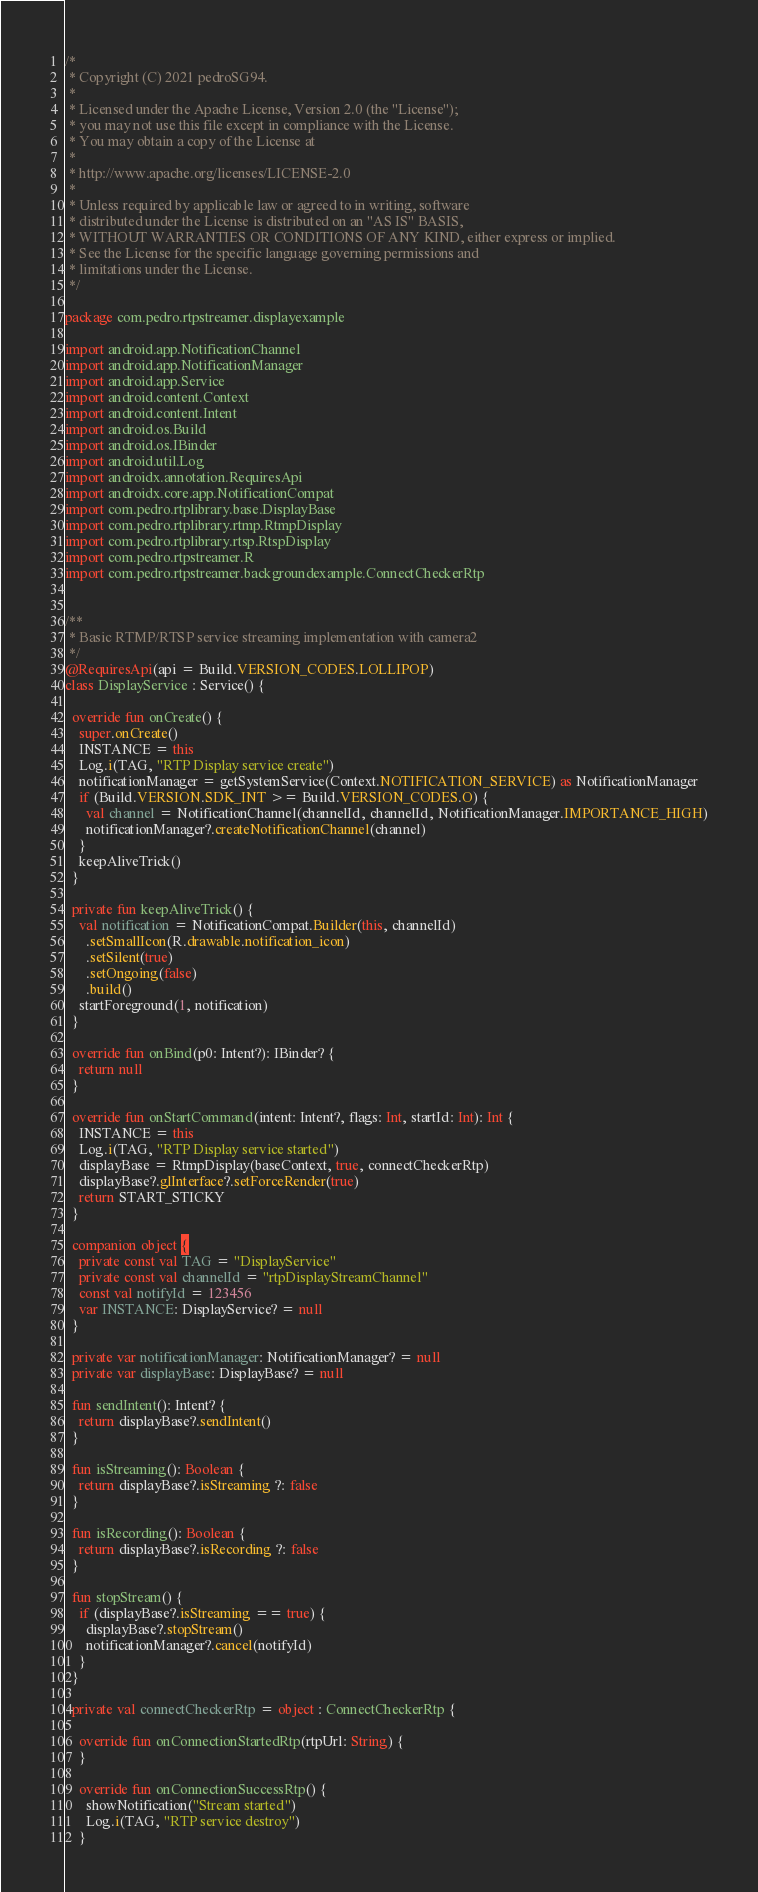<code> <loc_0><loc_0><loc_500><loc_500><_Kotlin_>/*
 * Copyright (C) 2021 pedroSG94.
 *
 * Licensed under the Apache License, Version 2.0 (the "License");
 * you may not use this file except in compliance with the License.
 * You may obtain a copy of the License at
 *
 * http://www.apache.org/licenses/LICENSE-2.0
 *
 * Unless required by applicable law or agreed to in writing, software
 * distributed under the License is distributed on an "AS IS" BASIS,
 * WITHOUT WARRANTIES OR CONDITIONS OF ANY KIND, either express or implied.
 * See the License for the specific language governing permissions and
 * limitations under the License.
 */

package com.pedro.rtpstreamer.displayexample

import android.app.NotificationChannel
import android.app.NotificationManager
import android.app.Service
import android.content.Context
import android.content.Intent
import android.os.Build
import android.os.IBinder
import android.util.Log
import androidx.annotation.RequiresApi
import androidx.core.app.NotificationCompat
import com.pedro.rtplibrary.base.DisplayBase
import com.pedro.rtplibrary.rtmp.RtmpDisplay
import com.pedro.rtplibrary.rtsp.RtspDisplay
import com.pedro.rtpstreamer.R
import com.pedro.rtpstreamer.backgroundexample.ConnectCheckerRtp


/**
 * Basic RTMP/RTSP service streaming implementation with camera2
 */
@RequiresApi(api = Build.VERSION_CODES.LOLLIPOP)
class DisplayService : Service() {

  override fun onCreate() {
    super.onCreate()
    INSTANCE = this
    Log.i(TAG, "RTP Display service create")
    notificationManager = getSystemService(Context.NOTIFICATION_SERVICE) as NotificationManager
    if (Build.VERSION.SDK_INT >= Build.VERSION_CODES.O) {
      val channel = NotificationChannel(channelId, channelId, NotificationManager.IMPORTANCE_HIGH)
      notificationManager?.createNotificationChannel(channel)
    }
    keepAliveTrick()
  }

  private fun keepAliveTrick() {
    val notification = NotificationCompat.Builder(this, channelId)
      .setSmallIcon(R.drawable.notification_icon)
      .setSilent(true)
      .setOngoing(false)
      .build()
    startForeground(1, notification)
  }

  override fun onBind(p0: Intent?): IBinder? {
    return null
  }

  override fun onStartCommand(intent: Intent?, flags: Int, startId: Int): Int {
    INSTANCE = this
    Log.i(TAG, "RTP Display service started")
    displayBase = RtmpDisplay(baseContext, true, connectCheckerRtp)
    displayBase?.glInterface?.setForceRender(true)
    return START_STICKY
  }

  companion object {
    private const val TAG = "DisplayService"
    private const val channelId = "rtpDisplayStreamChannel"
    const val notifyId = 123456
    var INSTANCE: DisplayService? = null
  }

  private var notificationManager: NotificationManager? = null
  private var displayBase: DisplayBase? = null

  fun sendIntent(): Intent? {
    return displayBase?.sendIntent()
  }

  fun isStreaming(): Boolean {
    return displayBase?.isStreaming ?: false
  }

  fun isRecording(): Boolean {
    return displayBase?.isRecording ?: false
  }

  fun stopStream() {
    if (displayBase?.isStreaming == true) {
      displayBase?.stopStream()
      notificationManager?.cancel(notifyId)
    }
  }

  private val connectCheckerRtp = object : ConnectCheckerRtp {

    override fun onConnectionStartedRtp(rtpUrl: String) {
    }

    override fun onConnectionSuccessRtp() {
      showNotification("Stream started")
      Log.i(TAG, "RTP service destroy")
    }
</code> 